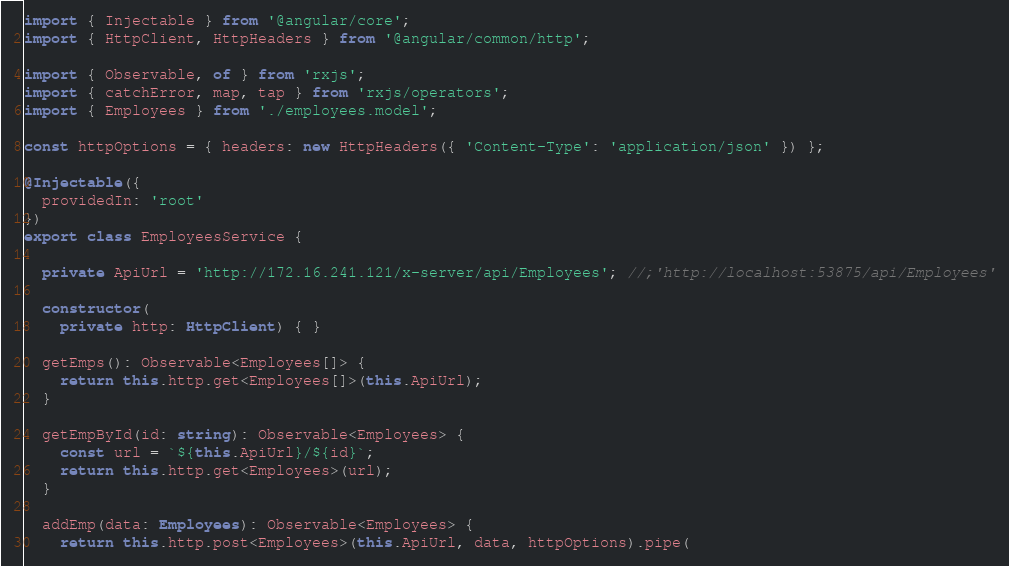<code> <loc_0><loc_0><loc_500><loc_500><_TypeScript_>import { Injectable } from '@angular/core';
import { HttpClient, HttpHeaders } from '@angular/common/http';

import { Observable, of } from 'rxjs';
import { catchError, map, tap } from 'rxjs/operators';
import { Employees } from './employees.model';

const httpOptions = { headers: new HttpHeaders({ 'Content-Type': 'application/json' }) };

@Injectable({
  providedIn: 'root'
})
export class EmployeesService {

  private ApiUrl = 'http://172.16.241.121/x-server/api/Employees'; //;'http://localhost:53875/api/Employees'

  constructor(
    private http: HttpClient) { }

  getEmps(): Observable<Employees[]> {
    return this.http.get<Employees[]>(this.ApiUrl);
  }

  getEmpById(id: string): Observable<Employees> {
    const url = `${this.ApiUrl}/${id}`;
    return this.http.get<Employees>(url);
  }

  addEmp(data: Employees): Observable<Employees> {
    return this.http.post<Employees>(this.ApiUrl, data, httpOptions).pipe(</code> 